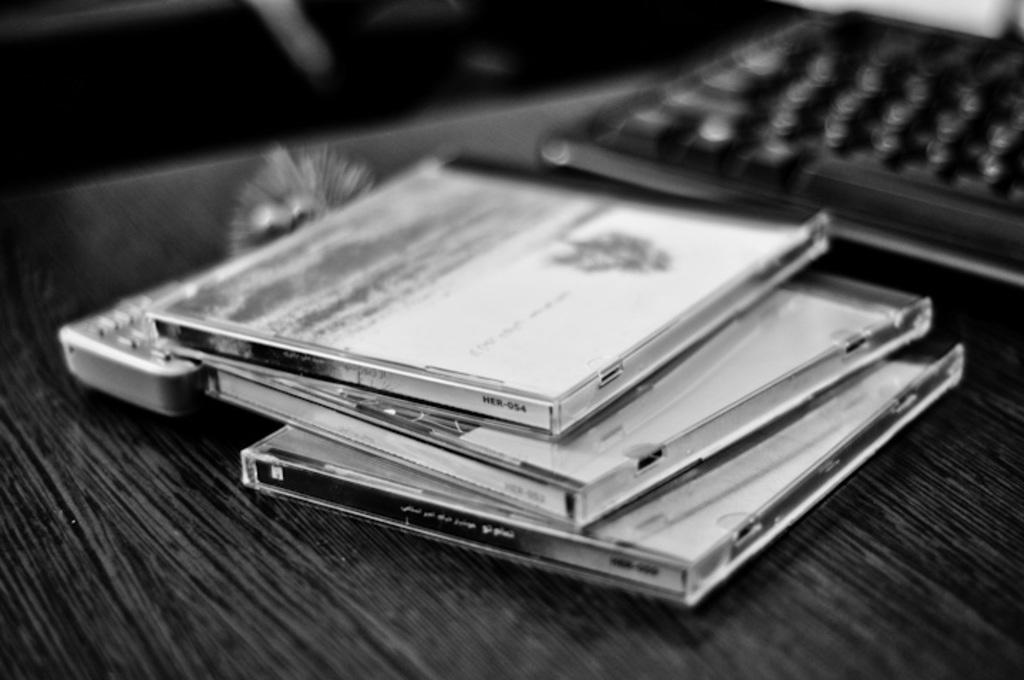<image>
Write a terse but informative summary of the picture. Three cd cases are resting on top of each other on a table and one of them is labeled HER-054 on its side. 